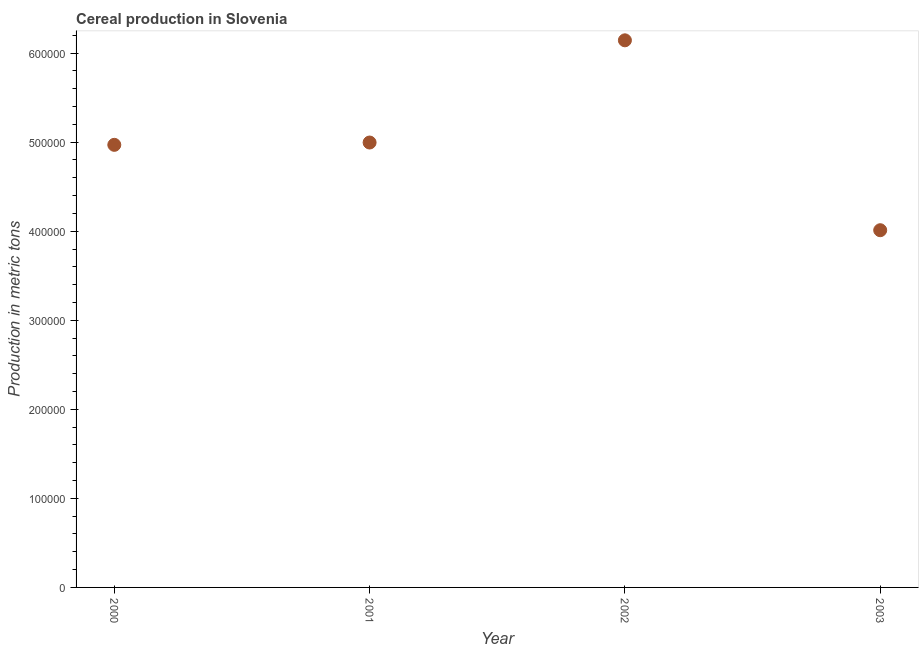What is the cereal production in 2001?
Give a very brief answer. 5.00e+05. Across all years, what is the maximum cereal production?
Your response must be concise. 6.14e+05. Across all years, what is the minimum cereal production?
Make the answer very short. 4.01e+05. In which year was the cereal production maximum?
Keep it short and to the point. 2002. In which year was the cereal production minimum?
Your response must be concise. 2003. What is the sum of the cereal production?
Your answer should be compact. 2.01e+06. What is the difference between the cereal production in 2001 and 2003?
Keep it short and to the point. 9.85e+04. What is the average cereal production per year?
Your answer should be very brief. 5.03e+05. What is the median cereal production?
Your answer should be compact. 4.98e+05. In how many years, is the cereal production greater than 220000 metric tons?
Offer a terse response. 4. Do a majority of the years between 2001 and 2003 (inclusive) have cereal production greater than 520000 metric tons?
Give a very brief answer. No. What is the ratio of the cereal production in 2000 to that in 2002?
Make the answer very short. 0.81. Is the cereal production in 2000 less than that in 2003?
Offer a very short reply. No. What is the difference between the highest and the second highest cereal production?
Your answer should be compact. 1.15e+05. What is the difference between the highest and the lowest cereal production?
Offer a very short reply. 2.13e+05. How many dotlines are there?
Your answer should be compact. 1. How many years are there in the graph?
Keep it short and to the point. 4. What is the difference between two consecutive major ticks on the Y-axis?
Your answer should be compact. 1.00e+05. Are the values on the major ticks of Y-axis written in scientific E-notation?
Offer a terse response. No. Does the graph contain any zero values?
Keep it short and to the point. No. Does the graph contain grids?
Give a very brief answer. No. What is the title of the graph?
Ensure brevity in your answer.  Cereal production in Slovenia. What is the label or title of the X-axis?
Give a very brief answer. Year. What is the label or title of the Y-axis?
Ensure brevity in your answer.  Production in metric tons. What is the Production in metric tons in 2000?
Your response must be concise. 4.97e+05. What is the Production in metric tons in 2001?
Offer a terse response. 5.00e+05. What is the Production in metric tons in 2002?
Keep it short and to the point. 6.14e+05. What is the Production in metric tons in 2003?
Provide a short and direct response. 4.01e+05. What is the difference between the Production in metric tons in 2000 and 2001?
Offer a terse response. -2601. What is the difference between the Production in metric tons in 2000 and 2002?
Ensure brevity in your answer.  -1.17e+05. What is the difference between the Production in metric tons in 2000 and 2003?
Offer a terse response. 9.59e+04. What is the difference between the Production in metric tons in 2001 and 2002?
Keep it short and to the point. -1.15e+05. What is the difference between the Production in metric tons in 2001 and 2003?
Keep it short and to the point. 9.85e+04. What is the difference between the Production in metric tons in 2002 and 2003?
Provide a short and direct response. 2.13e+05. What is the ratio of the Production in metric tons in 2000 to that in 2002?
Provide a succinct answer. 0.81. What is the ratio of the Production in metric tons in 2000 to that in 2003?
Ensure brevity in your answer.  1.24. What is the ratio of the Production in metric tons in 2001 to that in 2002?
Provide a succinct answer. 0.81. What is the ratio of the Production in metric tons in 2001 to that in 2003?
Provide a succinct answer. 1.25. What is the ratio of the Production in metric tons in 2002 to that in 2003?
Keep it short and to the point. 1.53. 